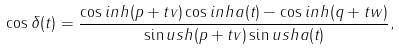<formula> <loc_0><loc_0><loc_500><loc_500>\cos \delta ( t ) = \frac { \cos i n h ( p + t v ) \cos i n h a ( t ) - \cos i n h ( q + t w ) } { \sin u s h ( p + t v ) \sin u s h a ( t ) } ,</formula> 